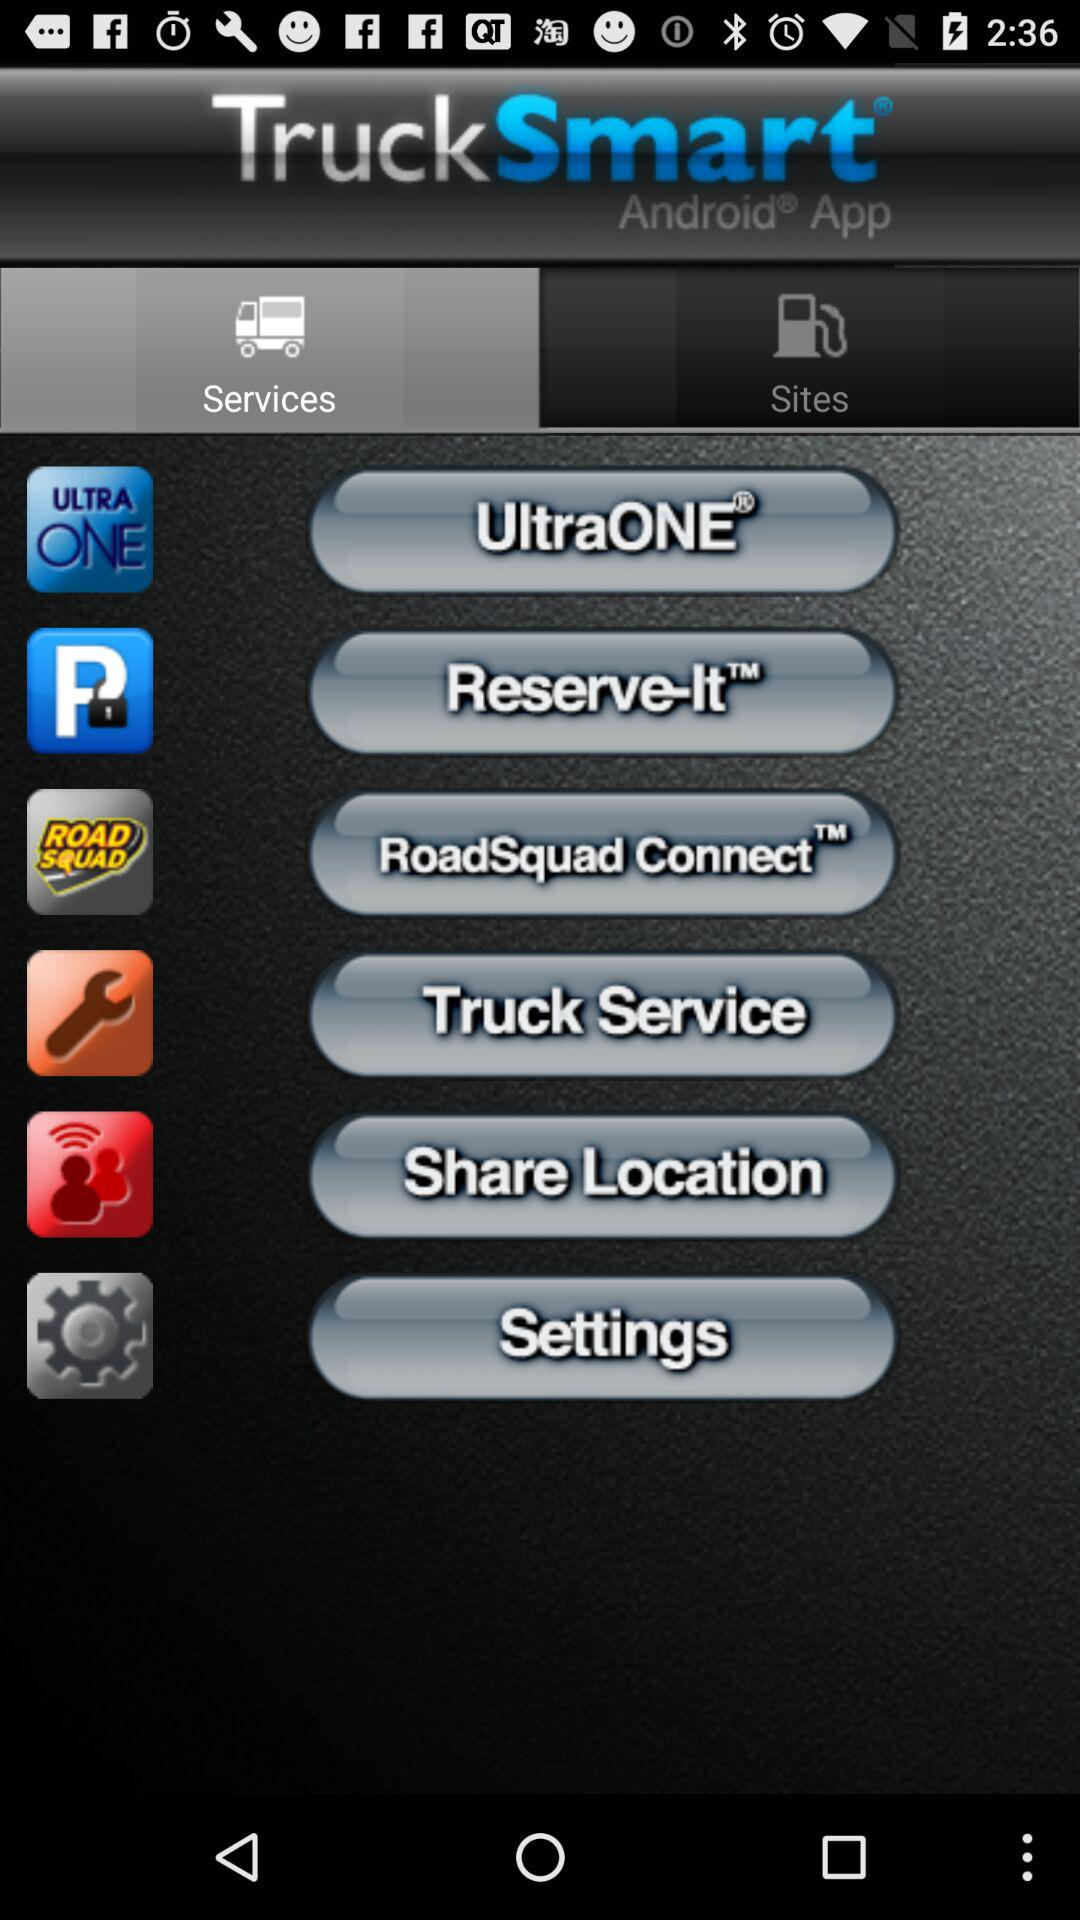What is the application name? The application name is "TruckSmart". 